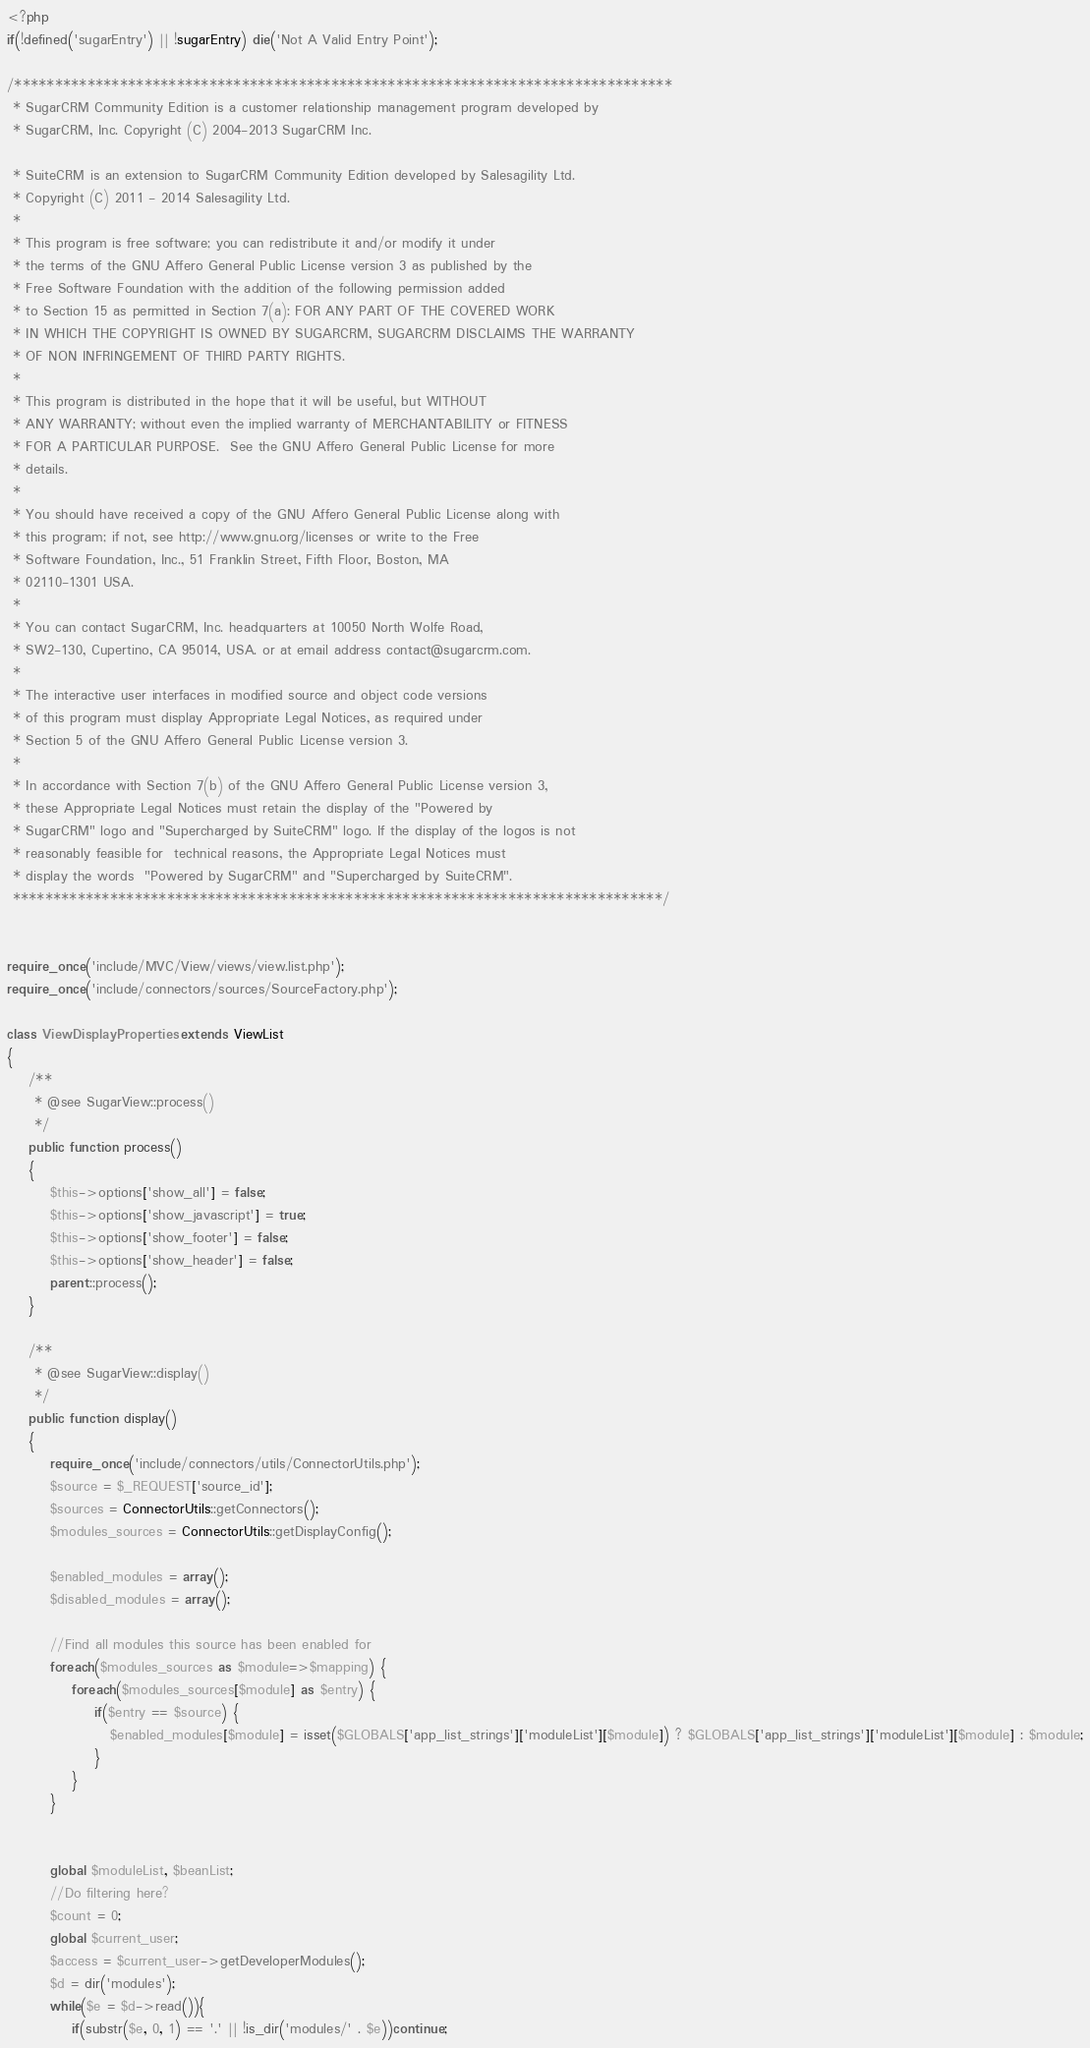<code> <loc_0><loc_0><loc_500><loc_500><_PHP_><?php
if(!defined('sugarEntry') || !sugarEntry) die('Not A Valid Entry Point');

/*********************************************************************************
 * SugarCRM Community Edition is a customer relationship management program developed by
 * SugarCRM, Inc. Copyright (C) 2004-2013 SugarCRM Inc.

 * SuiteCRM is an extension to SugarCRM Community Edition developed by Salesagility Ltd.
 * Copyright (C) 2011 - 2014 Salesagility Ltd.
 *
 * This program is free software; you can redistribute it and/or modify it under
 * the terms of the GNU Affero General Public License version 3 as published by the
 * Free Software Foundation with the addition of the following permission added
 * to Section 15 as permitted in Section 7(a): FOR ANY PART OF THE COVERED WORK
 * IN WHICH THE COPYRIGHT IS OWNED BY SUGARCRM, SUGARCRM DISCLAIMS THE WARRANTY
 * OF NON INFRINGEMENT OF THIRD PARTY RIGHTS.
 *
 * This program is distributed in the hope that it will be useful, but WITHOUT
 * ANY WARRANTY; without even the implied warranty of MERCHANTABILITY or FITNESS
 * FOR A PARTICULAR PURPOSE.  See the GNU Affero General Public License for more
 * details.
 *
 * You should have received a copy of the GNU Affero General Public License along with
 * this program; if not, see http://www.gnu.org/licenses or write to the Free
 * Software Foundation, Inc., 51 Franklin Street, Fifth Floor, Boston, MA
 * 02110-1301 USA.
 *
 * You can contact SugarCRM, Inc. headquarters at 10050 North Wolfe Road,
 * SW2-130, Cupertino, CA 95014, USA. or at email address contact@sugarcrm.com.
 *
 * The interactive user interfaces in modified source and object code versions
 * of this program must display Appropriate Legal Notices, as required under
 * Section 5 of the GNU Affero General Public License version 3.
 *
 * In accordance with Section 7(b) of the GNU Affero General Public License version 3,
 * these Appropriate Legal Notices must retain the display of the "Powered by
 * SugarCRM" logo and "Supercharged by SuiteCRM" logo. If the display of the logos is not
 * reasonably feasible for  technical reasons, the Appropriate Legal Notices must
 * display the words  "Powered by SugarCRM" and "Supercharged by SuiteCRM".
 ********************************************************************************/


require_once('include/MVC/View/views/view.list.php');
require_once('include/connectors/sources/SourceFactory.php');

class ViewDisplayProperties extends ViewList
{
 	/**
	 * @see SugarView::process()
	 */
	public function process()
	{
 		$this->options['show_all'] = false;
 		$this->options['show_javascript'] = true;
 		$this->options['show_footer'] = false;
 		$this->options['show_header'] = false;
 	    parent::process();
 	}

    /**
	 * @see SugarView::display()
	 */
	public function display()
	{
    	require_once('include/connectors/utils/ConnectorUtils.php');
    	$source = $_REQUEST['source_id'];
        $sources = ConnectorUtils::getConnectors();
        $modules_sources = ConnectorUtils::getDisplayConfig();

    	$enabled_modules = array();
    	$disabled_modules = array();

    	//Find all modules this source has been enabled for
    	foreach($modules_sources as $module=>$mapping) {
    		foreach($modules_sources[$module] as $entry) {
    			if($entry == $source) {
    			   $enabled_modules[$module] = isset($GLOBALS['app_list_strings']['moduleList'][$module]) ? $GLOBALS['app_list_strings']['moduleList'][$module] : $module;
    			}
    		}
   		}


    	global $moduleList, $beanList;
    	//Do filtering here?
    	$count = 0;
   		global $current_user;
		$access = $current_user->getDeveloperModules();
	    $d = dir('modules');
		while($e = $d->read()){
			if(substr($e, 0, 1) == '.' || !is_dir('modules/' . $e))continue;</code> 